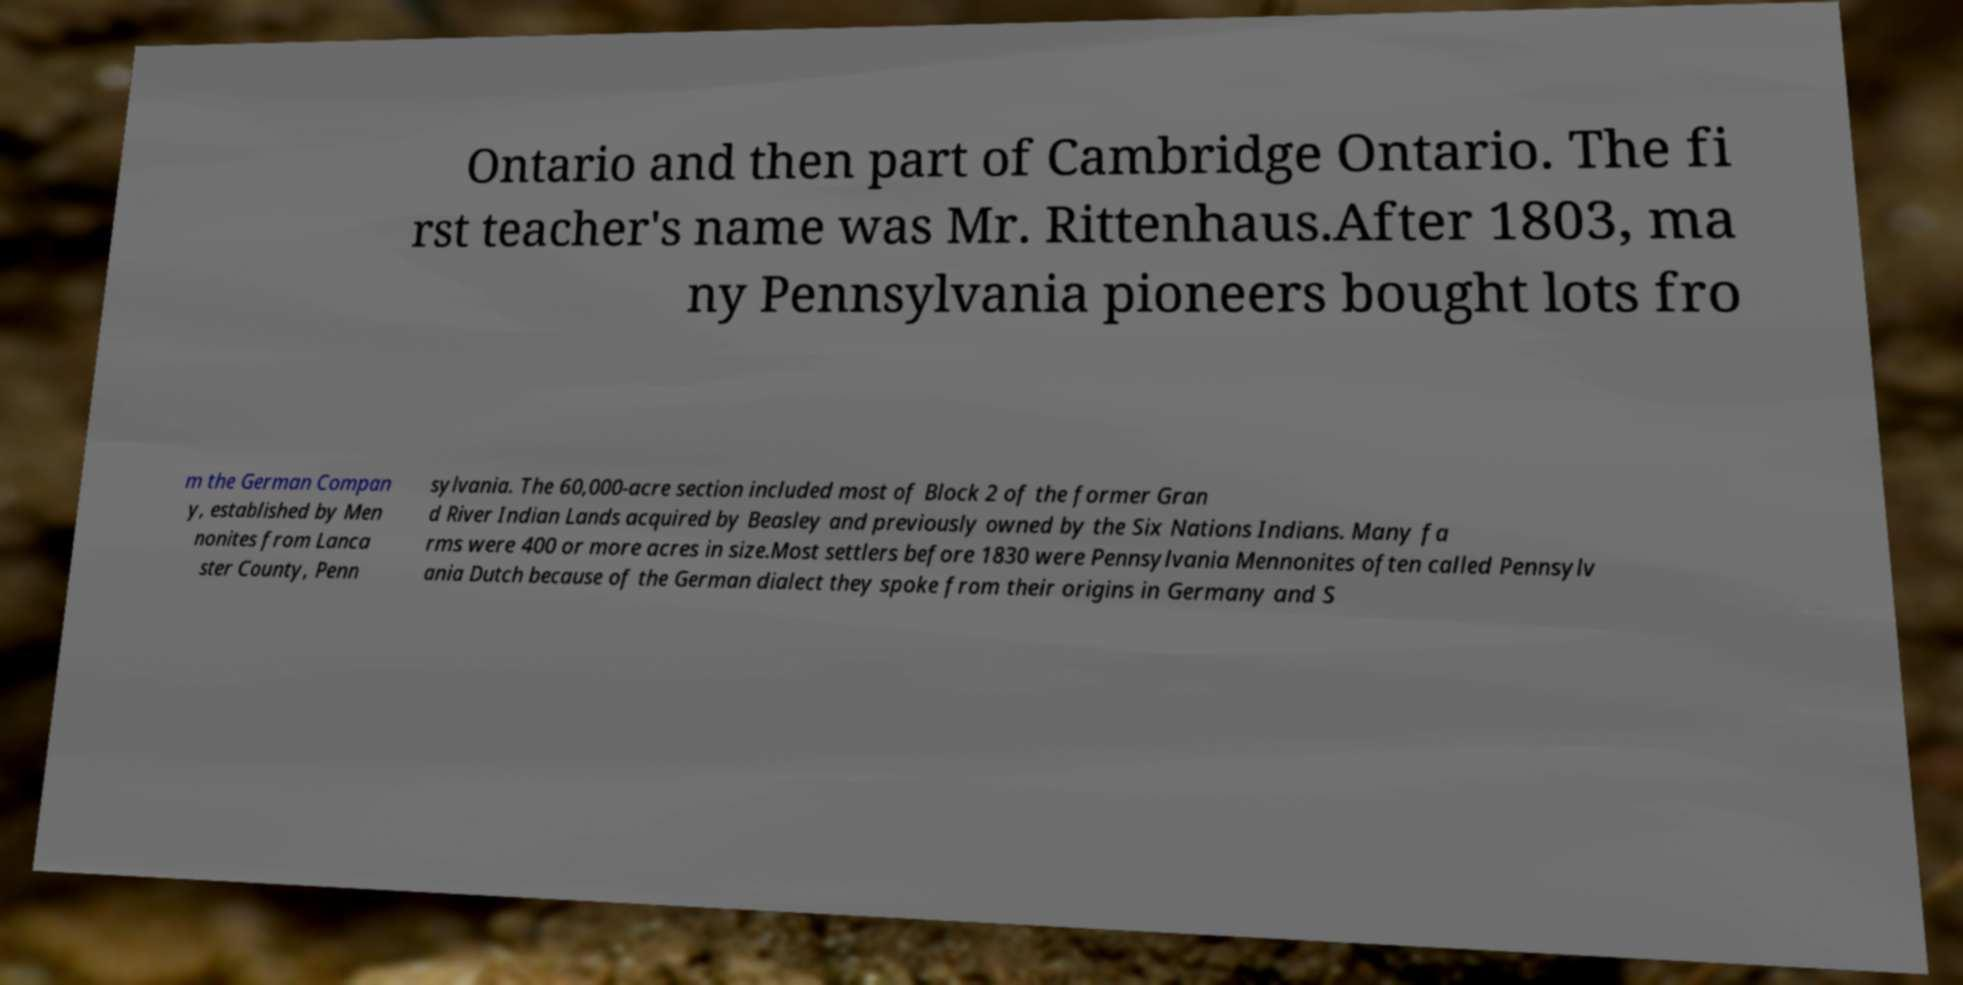Could you assist in decoding the text presented in this image and type it out clearly? Ontario and then part of Cambridge Ontario. The fi rst teacher's name was Mr. Rittenhaus.After 1803, ma ny Pennsylvania pioneers bought lots fro m the German Compan y, established by Men nonites from Lanca ster County, Penn sylvania. The 60,000-acre section included most of Block 2 of the former Gran d River Indian Lands acquired by Beasley and previously owned by the Six Nations Indians. Many fa rms were 400 or more acres in size.Most settlers before 1830 were Pennsylvania Mennonites often called Pennsylv ania Dutch because of the German dialect they spoke from their origins in Germany and S 